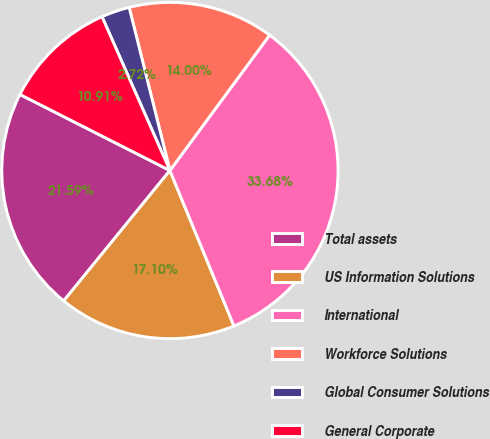Convert chart to OTSL. <chart><loc_0><loc_0><loc_500><loc_500><pie_chart><fcel>Total assets<fcel>US Information Solutions<fcel>International<fcel>Workforce Solutions<fcel>Global Consumer Solutions<fcel>General Corporate<nl><fcel>21.59%<fcel>17.1%<fcel>33.68%<fcel>14.0%<fcel>2.72%<fcel>10.91%<nl></chart> 